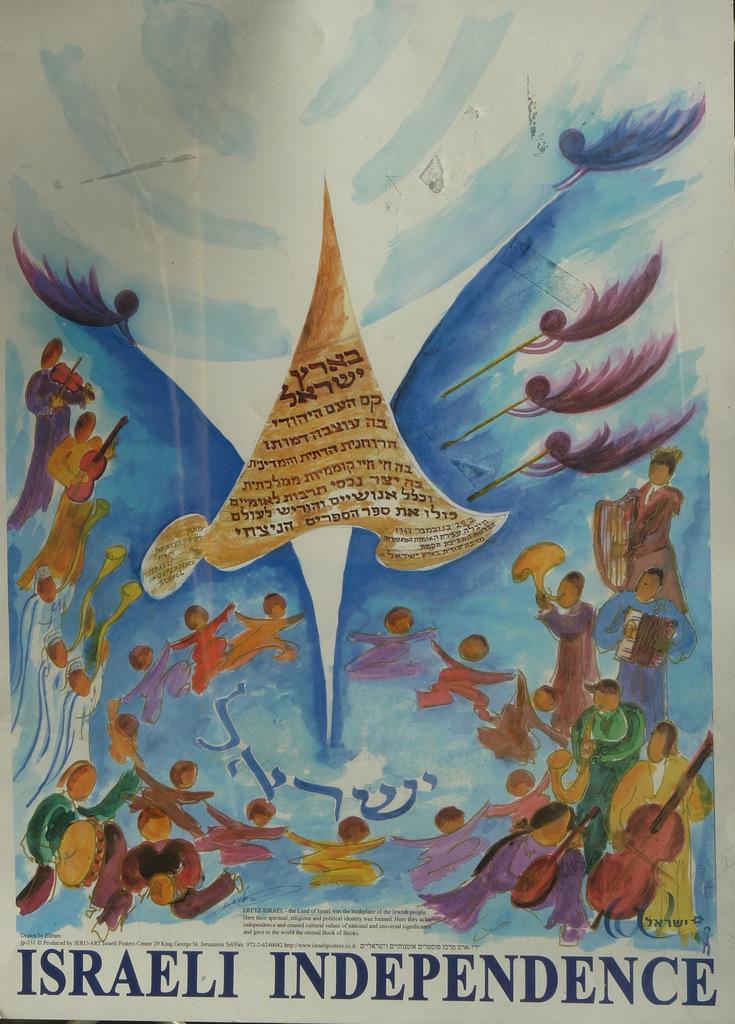How would you summarize this image in a sentence or two? In the image there is a paper with some text below and painting above it of some people playing musical instruments and dancing. 